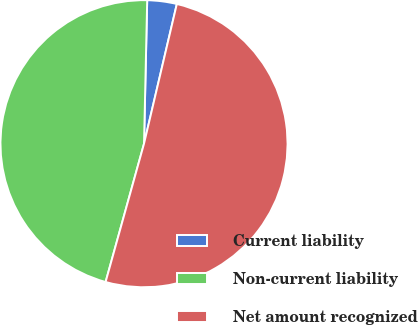<chart> <loc_0><loc_0><loc_500><loc_500><pie_chart><fcel>Current liability<fcel>Non-current liability<fcel>Net amount recognized<nl><fcel>3.32%<fcel>46.04%<fcel>50.64%<nl></chart> 